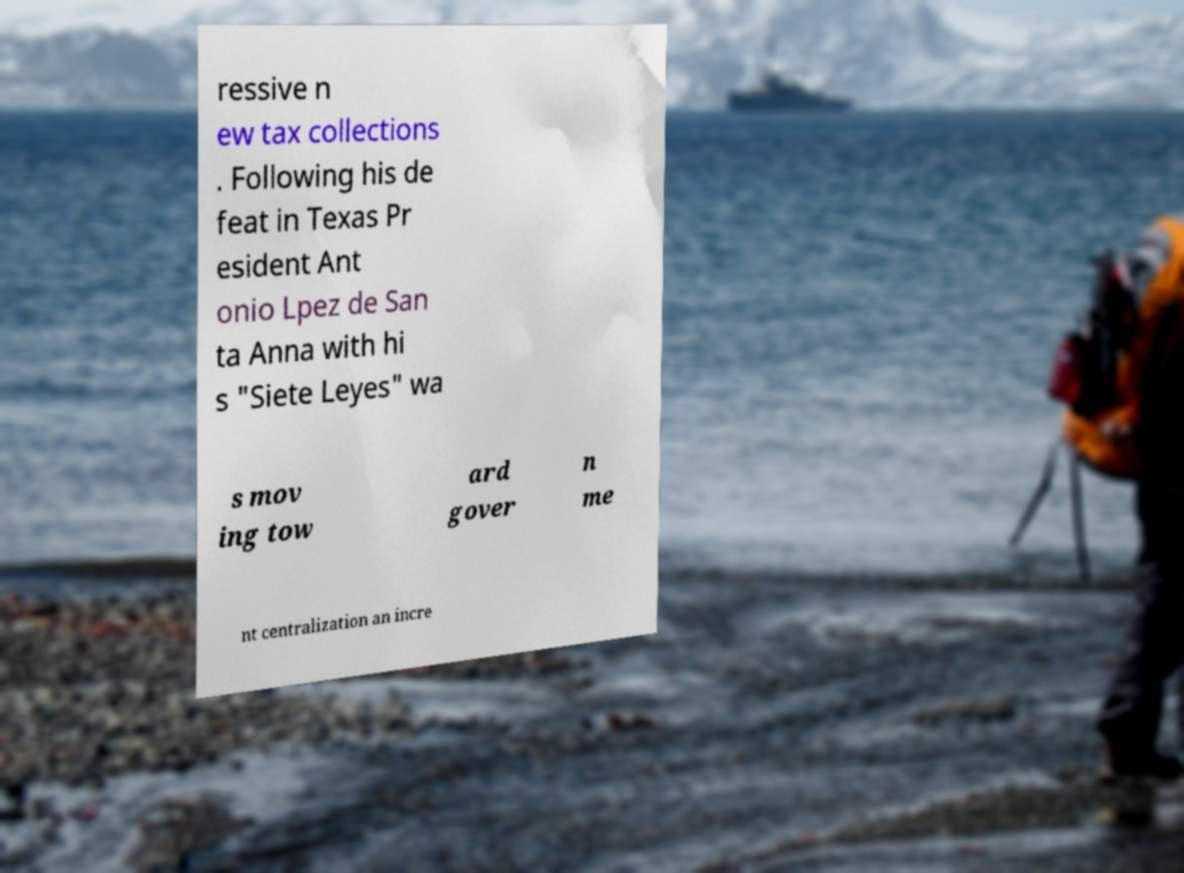Could you extract and type out the text from this image? ressive n ew tax collections . Following his de feat in Texas Pr esident Ant onio Lpez de San ta Anna with hi s "Siete Leyes" wa s mov ing tow ard gover n me nt centralization an incre 